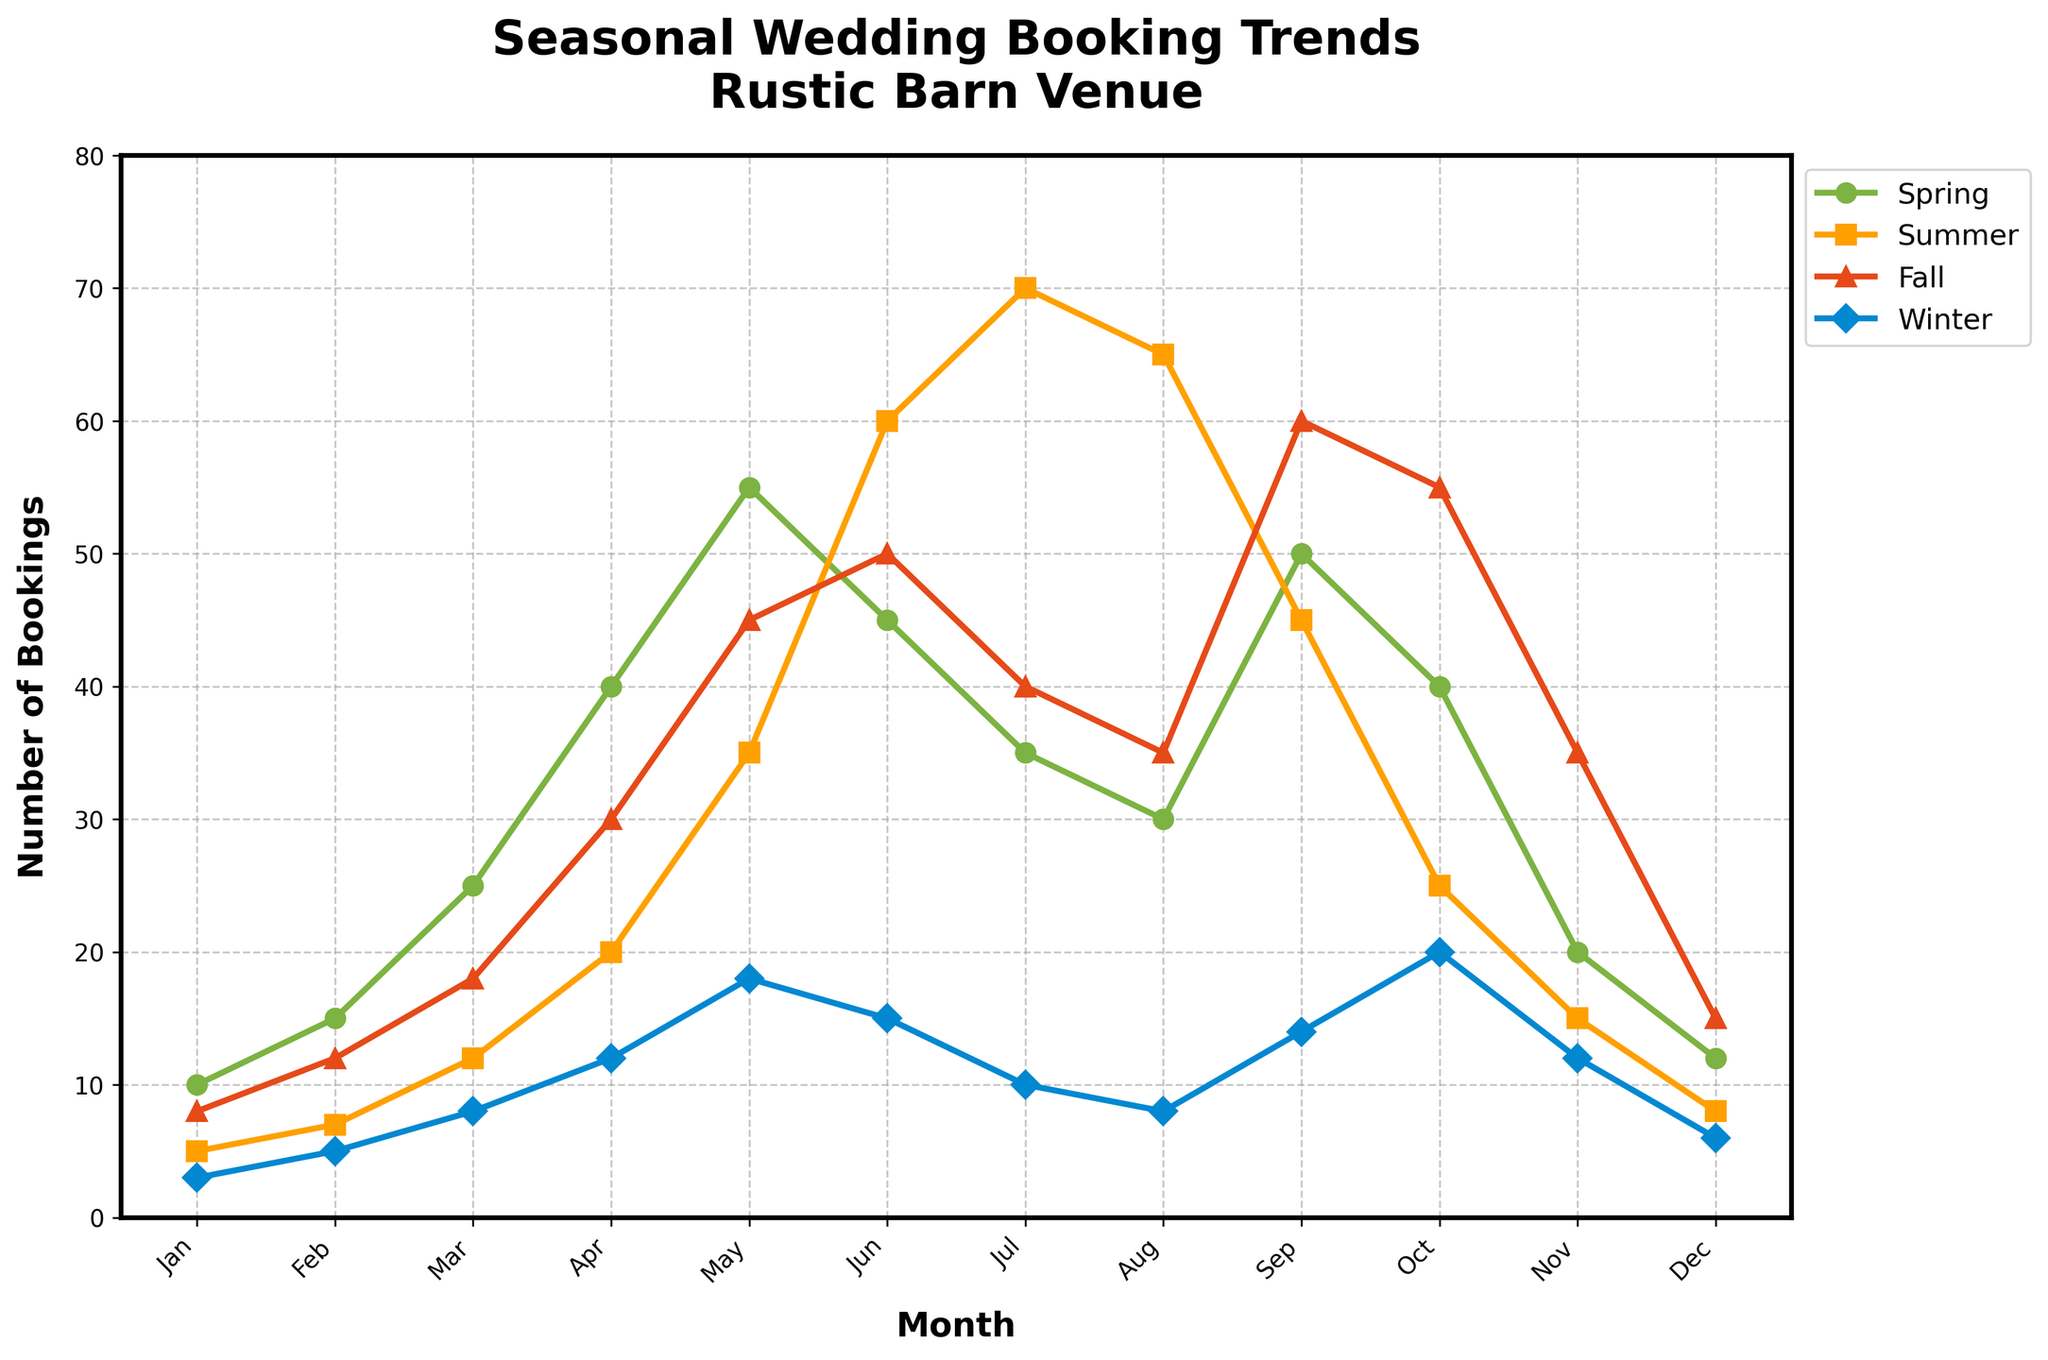Which month has the highest number of bookings overall, across all seasons? To find the answer, look at each month and add up the bookings from all four seasons. The month with the highest total is the answer. In this case, May has the highest number of bookings: 153 (Spring: 55, Summer: 35, Fall: 45, Winter: 18).
Answer: May Which season experiences the most fluctuation in bookings throughout the year? To determine the season with the most fluctuation, observe the range between the highest and lowest number of bookings for each season across the months. Summer shows the greatest fluctuation with bookings ranging from 5 in January to 70 in July, making a fluctuation range of 65.
Answer: Summer How do the bookings in September compare between Spring and Fall? Look at the bookings for September for both Spring and Fall. Spring has 50 bookings while Fall has 60 bookings. September bookings in Fall are 10 higher than in Spring.
Answer: Fall has 10 more What is the average number of bookings for Winter across the entire year? Sum up the number of bookings for Winter each month and then divide by 12 (the number of months). The sum is 127 (3 + 5 + 8 + 12 + 18 + 15 + 10 + 8 + 14 + 20 + 12 + 6) and the average is 127/12 = 10.58.
Answer: 10.58 Are there any months where Winter bookings are higher than Spring bookings? Compare the Winter and Spring bookings for each month. In December and January, Winter bookings (6 in Dec, 3 in Jan) are higher than Spring bookings (12 in Dec, 10 in Jan).
Answer: December and January During which month are the Summer bookings the lowest? Scan the summer bookings for each month and identify the month with the lowest value. The lowest value for Summer bookings is in January with 5 bookings.
Answer: January Which season has the highest number of bookings in August? Check the bookings in August for each season. Summer has the highest number of bookings in August with 65.
Answer: Summer Are the Spring bookings consistent throughout the year? To determine consistency, observe the Spring bookings across all months. The Spring bookings vary significantly, from a low of 10 in January to a high of 55 in May. This indicates that Spring bookings are not consistent.
Answer: No Which season sees the highest increase in bookings from February to March? Subtract the number of bookings in February from those in March for each season. Spring sees the highest increase from 15 to 25, an increase of 10.
Answer: Spring How do the Fall bookings in October compare to those in November? Look at the Fall bookings for October and November. Fall bookings are higher in October (55) compared to November (35).
Answer: Higher in October 